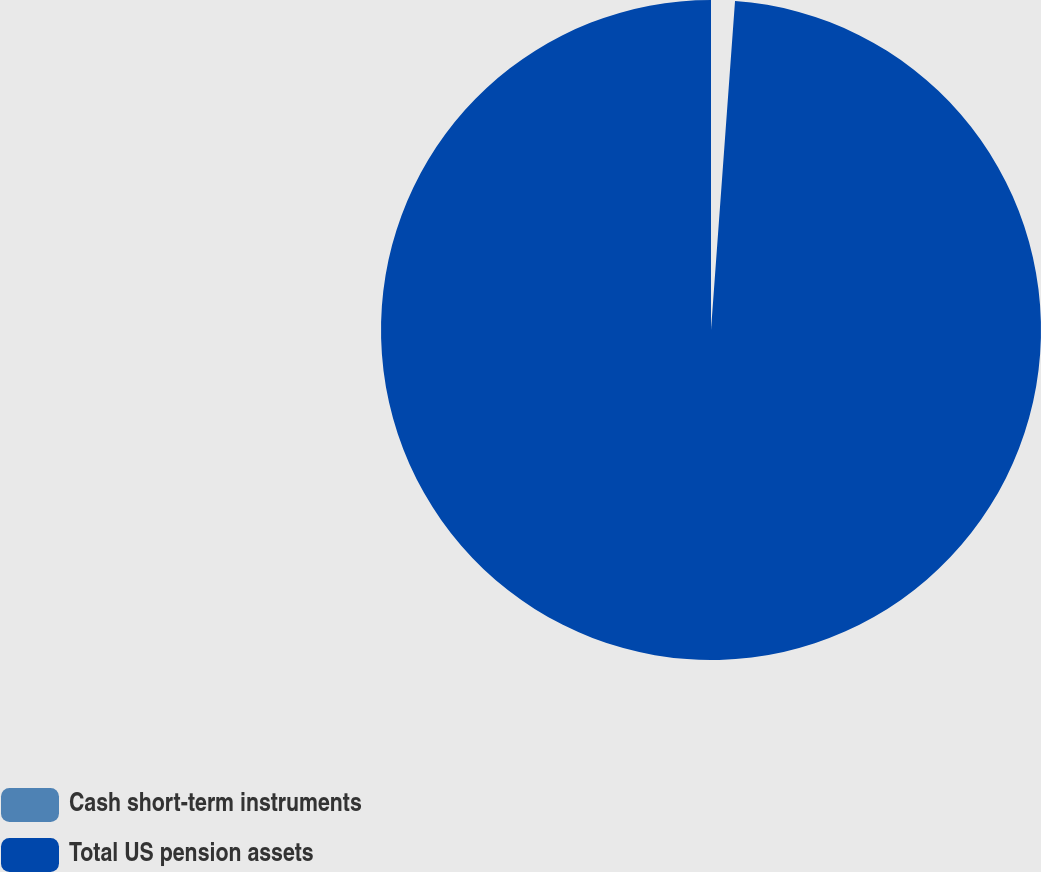<chart> <loc_0><loc_0><loc_500><loc_500><pie_chart><fcel>Cash short-term instruments<fcel>Total US pension assets<nl><fcel>1.16%<fcel>98.84%<nl></chart> 